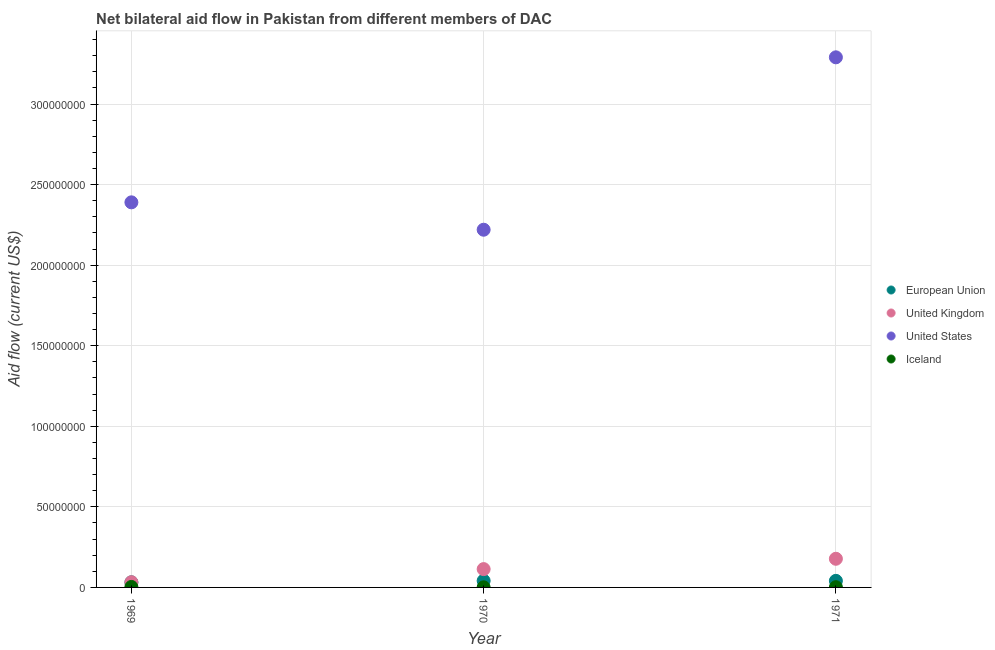How many different coloured dotlines are there?
Make the answer very short. 4. Is the number of dotlines equal to the number of legend labels?
Your response must be concise. Yes. What is the amount of aid given by iceland in 1970?
Provide a succinct answer. 6.00e+04. Across all years, what is the maximum amount of aid given by us?
Offer a very short reply. 3.29e+08. Across all years, what is the minimum amount of aid given by eu?
Your answer should be very brief. 3.18e+06. In which year was the amount of aid given by eu minimum?
Offer a terse response. 1969. What is the total amount of aid given by us in the graph?
Your answer should be compact. 7.90e+08. What is the difference between the amount of aid given by eu in 1969 and that in 1971?
Make the answer very short. -9.00e+05. What is the difference between the amount of aid given by eu in 1969 and the amount of aid given by uk in 1970?
Provide a short and direct response. -8.19e+06. What is the average amount of aid given by uk per year?
Your answer should be very brief. 1.08e+07. In the year 1971, what is the difference between the amount of aid given by iceland and amount of aid given by us?
Your answer should be compact. -3.29e+08. In how many years, is the amount of aid given by iceland greater than 270000000 US$?
Provide a succinct answer. 0. What is the ratio of the amount of aid given by us in 1969 to that in 1971?
Make the answer very short. 0.73. Is the amount of aid given by us in 1970 less than that in 1971?
Make the answer very short. Yes. Is the difference between the amount of aid given by iceland in 1969 and 1970 greater than the difference between the amount of aid given by eu in 1969 and 1970?
Your answer should be very brief. Yes. What is the difference between the highest and the second highest amount of aid given by iceland?
Your answer should be compact. 1.60e+05. What is the difference between the highest and the lowest amount of aid given by us?
Your response must be concise. 1.07e+08. In how many years, is the amount of aid given by eu greater than the average amount of aid given by eu taken over all years?
Your answer should be compact. 2. Is the sum of the amount of aid given by us in 1969 and 1970 greater than the maximum amount of aid given by eu across all years?
Your answer should be compact. Yes. Is it the case that in every year, the sum of the amount of aid given by eu and amount of aid given by uk is greater than the amount of aid given by us?
Ensure brevity in your answer.  No. Does the amount of aid given by iceland monotonically increase over the years?
Give a very brief answer. No. Is the amount of aid given by iceland strictly greater than the amount of aid given by uk over the years?
Provide a short and direct response. No. How many years are there in the graph?
Ensure brevity in your answer.  3. What is the difference between two consecutive major ticks on the Y-axis?
Your answer should be compact. 5.00e+07. Are the values on the major ticks of Y-axis written in scientific E-notation?
Provide a succinct answer. No. Does the graph contain grids?
Your answer should be very brief. Yes. How many legend labels are there?
Give a very brief answer. 4. How are the legend labels stacked?
Your answer should be compact. Vertical. What is the title of the graph?
Make the answer very short. Net bilateral aid flow in Pakistan from different members of DAC. Does "Australia" appear as one of the legend labels in the graph?
Ensure brevity in your answer.  No. What is the label or title of the X-axis?
Provide a short and direct response. Year. What is the label or title of the Y-axis?
Offer a very short reply. Aid flow (current US$). What is the Aid flow (current US$) of European Union in 1969?
Provide a succinct answer. 3.18e+06. What is the Aid flow (current US$) of United Kingdom in 1969?
Make the answer very short. 3.23e+06. What is the Aid flow (current US$) in United States in 1969?
Ensure brevity in your answer.  2.39e+08. What is the Aid flow (current US$) of Iceland in 1969?
Offer a terse response. 3.00e+05. What is the Aid flow (current US$) of European Union in 1970?
Give a very brief answer. 4.12e+06. What is the Aid flow (current US$) of United Kingdom in 1970?
Give a very brief answer. 1.14e+07. What is the Aid flow (current US$) in United States in 1970?
Your response must be concise. 2.22e+08. What is the Aid flow (current US$) in European Union in 1971?
Give a very brief answer. 4.08e+06. What is the Aid flow (current US$) in United Kingdom in 1971?
Provide a succinct answer. 1.78e+07. What is the Aid flow (current US$) in United States in 1971?
Make the answer very short. 3.29e+08. What is the Aid flow (current US$) in Iceland in 1971?
Your answer should be very brief. 1.40e+05. Across all years, what is the maximum Aid flow (current US$) in European Union?
Your answer should be compact. 4.12e+06. Across all years, what is the maximum Aid flow (current US$) of United Kingdom?
Make the answer very short. 1.78e+07. Across all years, what is the maximum Aid flow (current US$) in United States?
Ensure brevity in your answer.  3.29e+08. Across all years, what is the maximum Aid flow (current US$) of Iceland?
Provide a short and direct response. 3.00e+05. Across all years, what is the minimum Aid flow (current US$) in European Union?
Keep it short and to the point. 3.18e+06. Across all years, what is the minimum Aid flow (current US$) of United Kingdom?
Ensure brevity in your answer.  3.23e+06. Across all years, what is the minimum Aid flow (current US$) of United States?
Give a very brief answer. 2.22e+08. Across all years, what is the minimum Aid flow (current US$) of Iceland?
Provide a short and direct response. 6.00e+04. What is the total Aid flow (current US$) of European Union in the graph?
Keep it short and to the point. 1.14e+07. What is the total Aid flow (current US$) of United Kingdom in the graph?
Offer a very short reply. 3.24e+07. What is the total Aid flow (current US$) of United States in the graph?
Your answer should be compact. 7.90e+08. What is the total Aid flow (current US$) in Iceland in the graph?
Your response must be concise. 5.00e+05. What is the difference between the Aid flow (current US$) of European Union in 1969 and that in 1970?
Provide a short and direct response. -9.40e+05. What is the difference between the Aid flow (current US$) of United Kingdom in 1969 and that in 1970?
Ensure brevity in your answer.  -8.14e+06. What is the difference between the Aid flow (current US$) of United States in 1969 and that in 1970?
Ensure brevity in your answer.  1.70e+07. What is the difference between the Aid flow (current US$) of Iceland in 1969 and that in 1970?
Offer a terse response. 2.40e+05. What is the difference between the Aid flow (current US$) of European Union in 1969 and that in 1971?
Offer a very short reply. -9.00e+05. What is the difference between the Aid flow (current US$) in United Kingdom in 1969 and that in 1971?
Give a very brief answer. -1.46e+07. What is the difference between the Aid flow (current US$) in United States in 1969 and that in 1971?
Your response must be concise. -9.00e+07. What is the difference between the Aid flow (current US$) in Iceland in 1969 and that in 1971?
Your answer should be very brief. 1.60e+05. What is the difference between the Aid flow (current US$) in European Union in 1970 and that in 1971?
Your answer should be very brief. 4.00e+04. What is the difference between the Aid flow (current US$) of United Kingdom in 1970 and that in 1971?
Keep it short and to the point. -6.41e+06. What is the difference between the Aid flow (current US$) in United States in 1970 and that in 1971?
Your answer should be compact. -1.07e+08. What is the difference between the Aid flow (current US$) in Iceland in 1970 and that in 1971?
Ensure brevity in your answer.  -8.00e+04. What is the difference between the Aid flow (current US$) of European Union in 1969 and the Aid flow (current US$) of United Kingdom in 1970?
Your answer should be very brief. -8.19e+06. What is the difference between the Aid flow (current US$) of European Union in 1969 and the Aid flow (current US$) of United States in 1970?
Ensure brevity in your answer.  -2.19e+08. What is the difference between the Aid flow (current US$) in European Union in 1969 and the Aid flow (current US$) in Iceland in 1970?
Make the answer very short. 3.12e+06. What is the difference between the Aid flow (current US$) of United Kingdom in 1969 and the Aid flow (current US$) of United States in 1970?
Provide a succinct answer. -2.19e+08. What is the difference between the Aid flow (current US$) of United Kingdom in 1969 and the Aid flow (current US$) of Iceland in 1970?
Give a very brief answer. 3.17e+06. What is the difference between the Aid flow (current US$) of United States in 1969 and the Aid flow (current US$) of Iceland in 1970?
Your answer should be compact. 2.39e+08. What is the difference between the Aid flow (current US$) of European Union in 1969 and the Aid flow (current US$) of United Kingdom in 1971?
Give a very brief answer. -1.46e+07. What is the difference between the Aid flow (current US$) in European Union in 1969 and the Aid flow (current US$) in United States in 1971?
Give a very brief answer. -3.26e+08. What is the difference between the Aid flow (current US$) in European Union in 1969 and the Aid flow (current US$) in Iceland in 1971?
Make the answer very short. 3.04e+06. What is the difference between the Aid flow (current US$) of United Kingdom in 1969 and the Aid flow (current US$) of United States in 1971?
Your response must be concise. -3.26e+08. What is the difference between the Aid flow (current US$) in United Kingdom in 1969 and the Aid flow (current US$) in Iceland in 1971?
Offer a very short reply. 3.09e+06. What is the difference between the Aid flow (current US$) of United States in 1969 and the Aid flow (current US$) of Iceland in 1971?
Make the answer very short. 2.39e+08. What is the difference between the Aid flow (current US$) of European Union in 1970 and the Aid flow (current US$) of United Kingdom in 1971?
Give a very brief answer. -1.37e+07. What is the difference between the Aid flow (current US$) of European Union in 1970 and the Aid flow (current US$) of United States in 1971?
Keep it short and to the point. -3.25e+08. What is the difference between the Aid flow (current US$) in European Union in 1970 and the Aid flow (current US$) in Iceland in 1971?
Your response must be concise. 3.98e+06. What is the difference between the Aid flow (current US$) of United Kingdom in 1970 and the Aid flow (current US$) of United States in 1971?
Your answer should be compact. -3.18e+08. What is the difference between the Aid flow (current US$) in United Kingdom in 1970 and the Aid flow (current US$) in Iceland in 1971?
Offer a terse response. 1.12e+07. What is the difference between the Aid flow (current US$) in United States in 1970 and the Aid flow (current US$) in Iceland in 1971?
Make the answer very short. 2.22e+08. What is the average Aid flow (current US$) of European Union per year?
Offer a very short reply. 3.79e+06. What is the average Aid flow (current US$) of United Kingdom per year?
Your answer should be compact. 1.08e+07. What is the average Aid flow (current US$) in United States per year?
Your response must be concise. 2.63e+08. What is the average Aid flow (current US$) in Iceland per year?
Offer a terse response. 1.67e+05. In the year 1969, what is the difference between the Aid flow (current US$) of European Union and Aid flow (current US$) of United States?
Give a very brief answer. -2.36e+08. In the year 1969, what is the difference between the Aid flow (current US$) in European Union and Aid flow (current US$) in Iceland?
Provide a short and direct response. 2.88e+06. In the year 1969, what is the difference between the Aid flow (current US$) of United Kingdom and Aid flow (current US$) of United States?
Offer a terse response. -2.36e+08. In the year 1969, what is the difference between the Aid flow (current US$) in United Kingdom and Aid flow (current US$) in Iceland?
Offer a very short reply. 2.93e+06. In the year 1969, what is the difference between the Aid flow (current US$) of United States and Aid flow (current US$) of Iceland?
Provide a short and direct response. 2.39e+08. In the year 1970, what is the difference between the Aid flow (current US$) in European Union and Aid flow (current US$) in United Kingdom?
Make the answer very short. -7.25e+06. In the year 1970, what is the difference between the Aid flow (current US$) in European Union and Aid flow (current US$) in United States?
Provide a succinct answer. -2.18e+08. In the year 1970, what is the difference between the Aid flow (current US$) of European Union and Aid flow (current US$) of Iceland?
Offer a terse response. 4.06e+06. In the year 1970, what is the difference between the Aid flow (current US$) of United Kingdom and Aid flow (current US$) of United States?
Offer a very short reply. -2.11e+08. In the year 1970, what is the difference between the Aid flow (current US$) in United Kingdom and Aid flow (current US$) in Iceland?
Keep it short and to the point. 1.13e+07. In the year 1970, what is the difference between the Aid flow (current US$) in United States and Aid flow (current US$) in Iceland?
Your answer should be very brief. 2.22e+08. In the year 1971, what is the difference between the Aid flow (current US$) of European Union and Aid flow (current US$) of United Kingdom?
Keep it short and to the point. -1.37e+07. In the year 1971, what is the difference between the Aid flow (current US$) of European Union and Aid flow (current US$) of United States?
Keep it short and to the point. -3.25e+08. In the year 1971, what is the difference between the Aid flow (current US$) in European Union and Aid flow (current US$) in Iceland?
Offer a very short reply. 3.94e+06. In the year 1971, what is the difference between the Aid flow (current US$) of United Kingdom and Aid flow (current US$) of United States?
Offer a terse response. -3.11e+08. In the year 1971, what is the difference between the Aid flow (current US$) of United Kingdom and Aid flow (current US$) of Iceland?
Your response must be concise. 1.76e+07. In the year 1971, what is the difference between the Aid flow (current US$) of United States and Aid flow (current US$) of Iceland?
Offer a terse response. 3.29e+08. What is the ratio of the Aid flow (current US$) of European Union in 1969 to that in 1970?
Ensure brevity in your answer.  0.77. What is the ratio of the Aid flow (current US$) in United Kingdom in 1969 to that in 1970?
Make the answer very short. 0.28. What is the ratio of the Aid flow (current US$) in United States in 1969 to that in 1970?
Provide a short and direct response. 1.08. What is the ratio of the Aid flow (current US$) of Iceland in 1969 to that in 1970?
Your response must be concise. 5. What is the ratio of the Aid flow (current US$) in European Union in 1969 to that in 1971?
Keep it short and to the point. 0.78. What is the ratio of the Aid flow (current US$) in United Kingdom in 1969 to that in 1971?
Make the answer very short. 0.18. What is the ratio of the Aid flow (current US$) in United States in 1969 to that in 1971?
Offer a terse response. 0.73. What is the ratio of the Aid flow (current US$) of Iceland in 1969 to that in 1971?
Offer a very short reply. 2.14. What is the ratio of the Aid flow (current US$) of European Union in 1970 to that in 1971?
Offer a terse response. 1.01. What is the ratio of the Aid flow (current US$) of United Kingdom in 1970 to that in 1971?
Keep it short and to the point. 0.64. What is the ratio of the Aid flow (current US$) of United States in 1970 to that in 1971?
Offer a terse response. 0.67. What is the ratio of the Aid flow (current US$) in Iceland in 1970 to that in 1971?
Your response must be concise. 0.43. What is the difference between the highest and the second highest Aid flow (current US$) in European Union?
Offer a very short reply. 4.00e+04. What is the difference between the highest and the second highest Aid flow (current US$) in United Kingdom?
Your response must be concise. 6.41e+06. What is the difference between the highest and the second highest Aid flow (current US$) of United States?
Provide a short and direct response. 9.00e+07. What is the difference between the highest and the second highest Aid flow (current US$) in Iceland?
Provide a short and direct response. 1.60e+05. What is the difference between the highest and the lowest Aid flow (current US$) in European Union?
Provide a succinct answer. 9.40e+05. What is the difference between the highest and the lowest Aid flow (current US$) of United Kingdom?
Ensure brevity in your answer.  1.46e+07. What is the difference between the highest and the lowest Aid flow (current US$) in United States?
Offer a very short reply. 1.07e+08. 